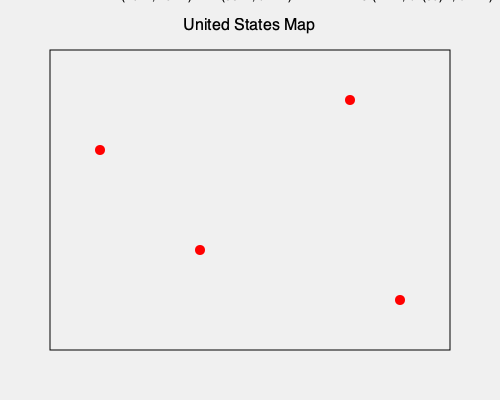Based on the coordinates provided on the map, which point represents the location of the University of Texas at Austin? To answer this question, we need to follow these steps:

1. Recall that the University of Texas at Austin is located in Austin, Texas.

2. Austin, Texas is located at approximately 30°N latitude and 97°W longitude.

3. Examine the coordinates provided for each point on the map:
   A: 40°N, 75°W
   B: 33°N, 84°W
   C: 42°N, 87°W
   D: 30°N, 97°W

4. Compare the coordinates of Austin with the given points:
   Point D has coordinates 30°N, 97°W, which match the location of Austin, Texas.

5. Therefore, point D represents the location of the University of Texas at Austin.

This exercise helps students practice identifying locations based on geographic coordinates, which is an important skill when researching and comparing college locations across the United States.
Answer: D 